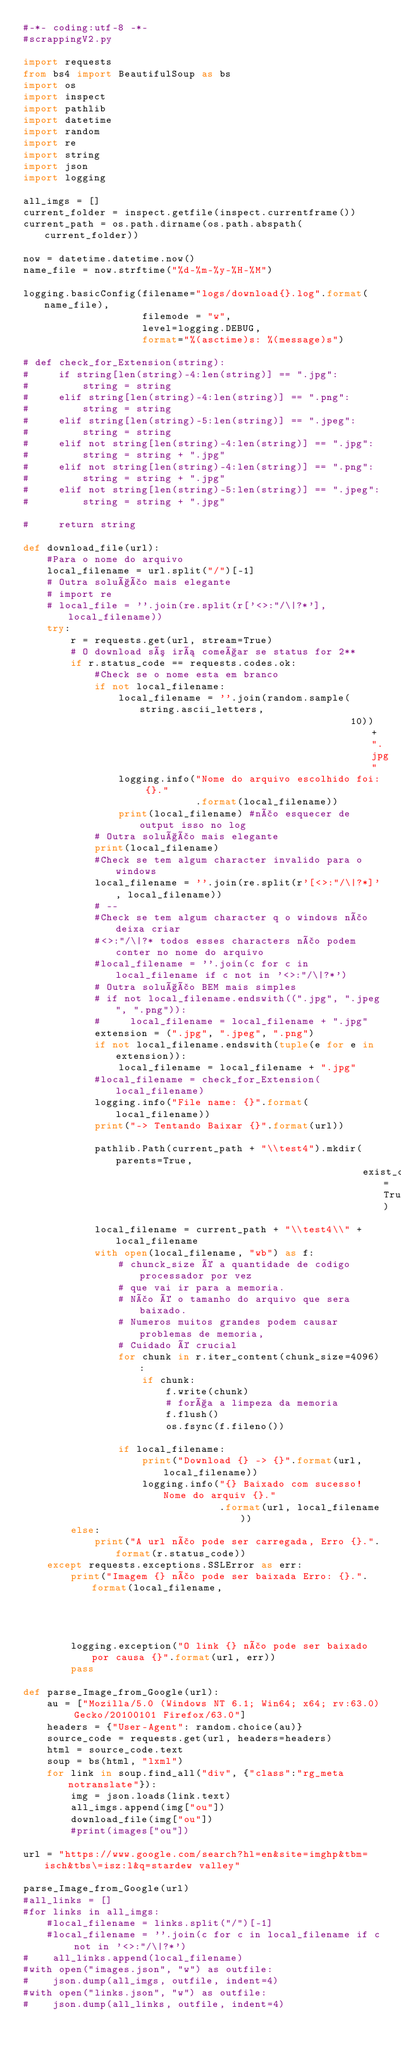<code> <loc_0><loc_0><loc_500><loc_500><_Python_>#-*- coding:utf-8 -*-
#scrappingV2.py

import requests
from bs4 import BeautifulSoup as bs
import os
import inspect
import pathlib
import datetime
import random
import re
import string
import json
import logging

all_imgs = []
current_folder = inspect.getfile(inspect.currentframe())
current_path = os.path.dirname(os.path.abspath(current_folder))

now = datetime.datetime.now()
name_file = now.strftime("%d-%m-%y-%H-%M")

logging.basicConfig(filename="logs/download{}.log".format(name_file),
                    filemode = "w",
                    level=logging.DEBUG,
                    format="%(asctime)s: %(message)s")

# def check_for_Extension(string):
#     if string[len(string)-4:len(string)] == ".jpg":
#         string = string
#     elif string[len(string)-4:len(string)] == ".png":
#         string = string
#     elif string[len(string)-5:len(string)] == ".jpeg":
#         string = string
#     elif not string[len(string)-4:len(string)] == ".jpg":
#         string = string + ".jpg"
#     elif not string[len(string)-4:len(string)] == ".png":
#         string = string + ".jpg"
#     elif not string[len(string)-5:len(string)] == ".jpeg":
#         string = string + ".jpg"

#     return string

def download_file(url):
    #Para o nome do arquivo
    local_filename = url.split("/")[-1]
    # Outra solução mais elegante
    # import re
    # local_file = ''.join(re.split(r['<>:"/\|?*'], local_filename))
    try:
        r = requests.get(url, stream=True)
        # O download só irá começar se status for 2**
        if r.status_code == requests.codes.ok:
            #Check se o nome esta em branco
            if not local_filename:
                local_filename = ''.join(random.sample(string.ascii_letters,
                                                       10)) + ".jpg"
                logging.info("Nome do arquivo escolhido foi: {}."
                             .format(local_filename))
                print(local_filename) #não esquecer de output isso no log
            # Outra solução mais elegante
            print(local_filename)
            #Check se tem algum character invalido para o windows
            local_filename = ''.join(re.split(r'[<>:"/\|?*]', local_filename))
            # --
            #Check se tem algum character q o windows não deixa criar
            #<>:"/\|?* todos esses characters não podem conter no nome do arquivo
            #local_filename = ''.join(c for c in local_filename if c not in '<>:"/\|?*')
            # Outra solução BEM mais simples
            # if not local_filename.endswith((".jpg", ".jpeg", ".png")):
            #     local_filename = local_filename + ".jpg"
            extension = (".jpg", ".jpeg", ".png")
            if not local_filename.endswith(tuple(e for e in extension)):
                local_filename = local_filename + ".jpg"
            #local_filename = check_for_Extension(local_filename)
            logging.info("File name: {}".format(local_filename))
            print("-> Tentando Baixar {}".format(url))
            
            pathlib.Path(current_path + "\\test4").mkdir(parents=True,
                                                         exist_ok=True)
            local_filename = current_path + "\\test4\\" + local_filename
            with open(local_filename, "wb") as f:
                # chunck_size é a quantidade de codigo processador por vez
                # que vai ir para a memoria.
                # Não é o tamanho do arquivo que sera baixado.
                # Numeros muitos grandes podem causar problemas de memoria,
                # Cuidado é crucial
                for chunk in r.iter_content(chunk_size=4096):
                    if chunk:
                        f.write(chunk)
                        # força a limpeza da memoria
                        f.flush()
                        os.fsync(f.fileno())

                if local_filename:
                    print("Download {} -> {}".format(url, local_filename))
                    logging.info("{} Baixado com sucesso! Nome do arquiv {}."
                                 .format(url, local_filename))
        else:
            print("A url não pode ser carregada, Erro {}.".format(r.status_code))
    except requests.exceptions.SSLError as err:
        print("Imagem {} não pode ser baixada Erro: {}.".format(local_filename,
                                                                err))
        logging.exception("O link {} não pode ser baixado por causa {}".format(url, err))
        pass

def parse_Image_from_Google(url):
    au = ["Mozilla/5.0 (Windows NT 6.1; Win64; x64; rv:63.0) Gecko/20100101 Firefox/63.0"]
    headers = {"User-Agent": random.choice(au)}
    source_code = requests.get(url, headers=headers)
    html = source_code.text
    soup = bs(html, "lxml")
    for link in soup.find_all("div", {"class":"rg_meta notranslate"}):
        img = json.loads(link.text)
        all_imgs.append(img["ou"])
        download_file(img["ou"])
        #print(images["ou"])

url = "https://www.google.com/search?hl=en&site=imghp&tbm=isch&tbs\=isz:l&q=stardew valley"

parse_Image_from_Google(url)
#all_links = []
#for links in all_imgs:
    #local_filename = links.split("/")[-1]
    #local_filename = ''.join(c for c in local_filename if c not in '<>:"/\|?*')
#    all_links.append(local_filename)
#with open("images.json", "w") as outfile:
#    json.dump(all_imgs, outfile, indent=4)
#with open("links.json", "w") as outfile:
#    json.dump(all_links, outfile, indent=4)
</code> 